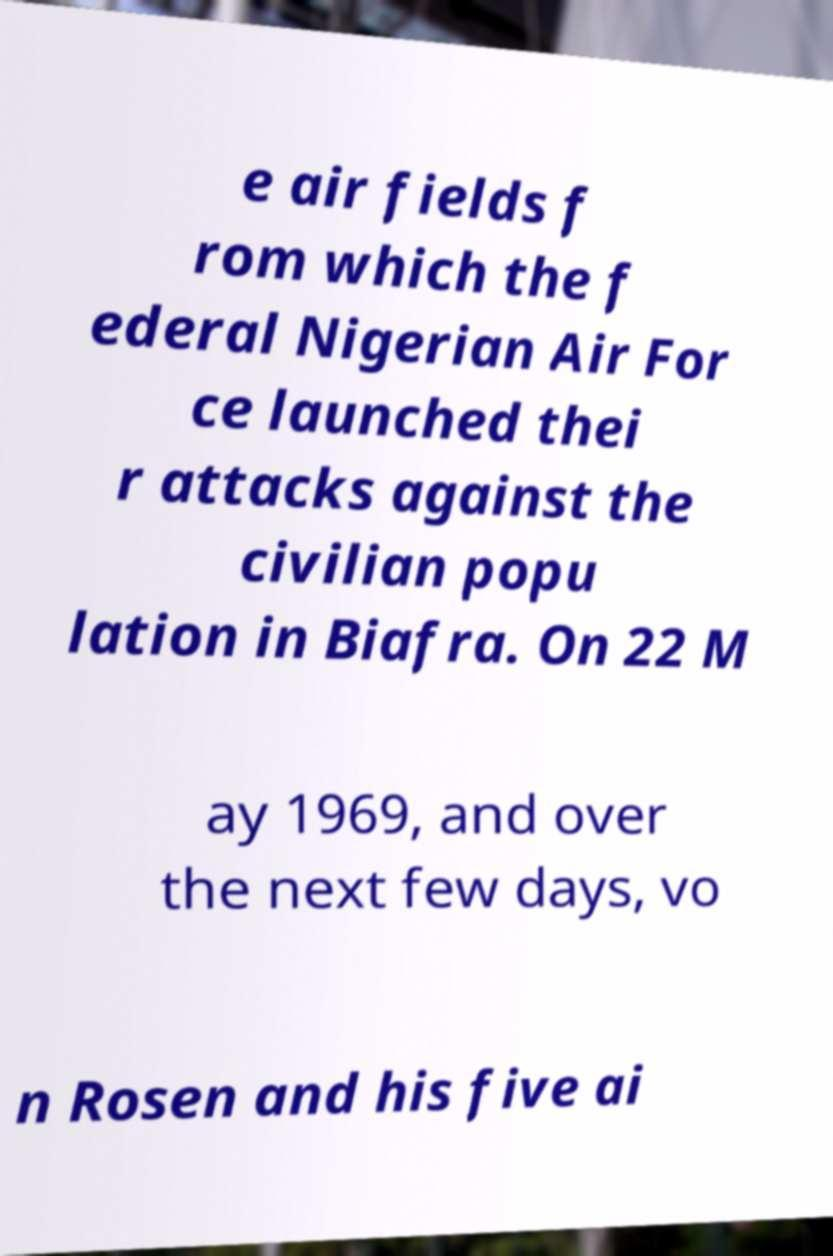Could you extract and type out the text from this image? e air fields f rom which the f ederal Nigerian Air For ce launched thei r attacks against the civilian popu lation in Biafra. On 22 M ay 1969, and over the next few days, vo n Rosen and his five ai 